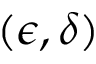Convert formula to latex. <formula><loc_0><loc_0><loc_500><loc_500>( \epsilon , \delta )</formula> 